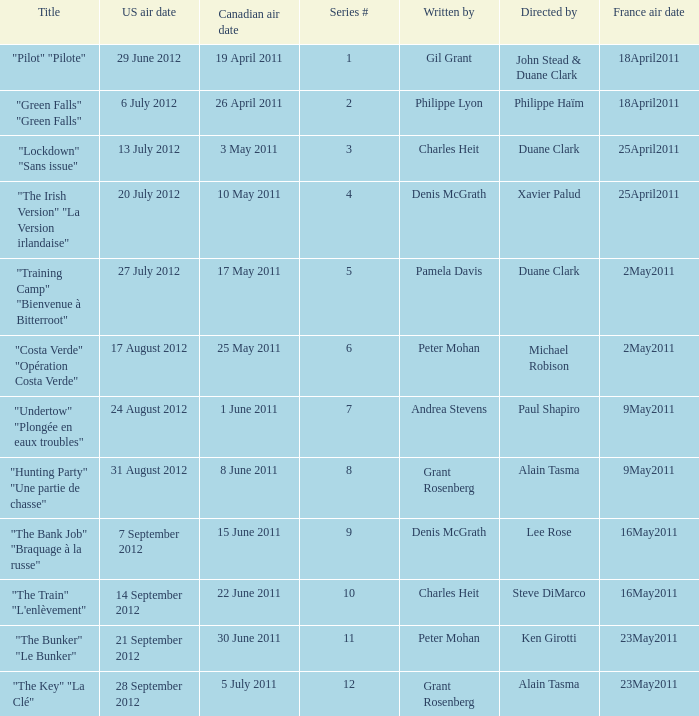What is the US air date when the director is ken girotti? 21 September 2012. 